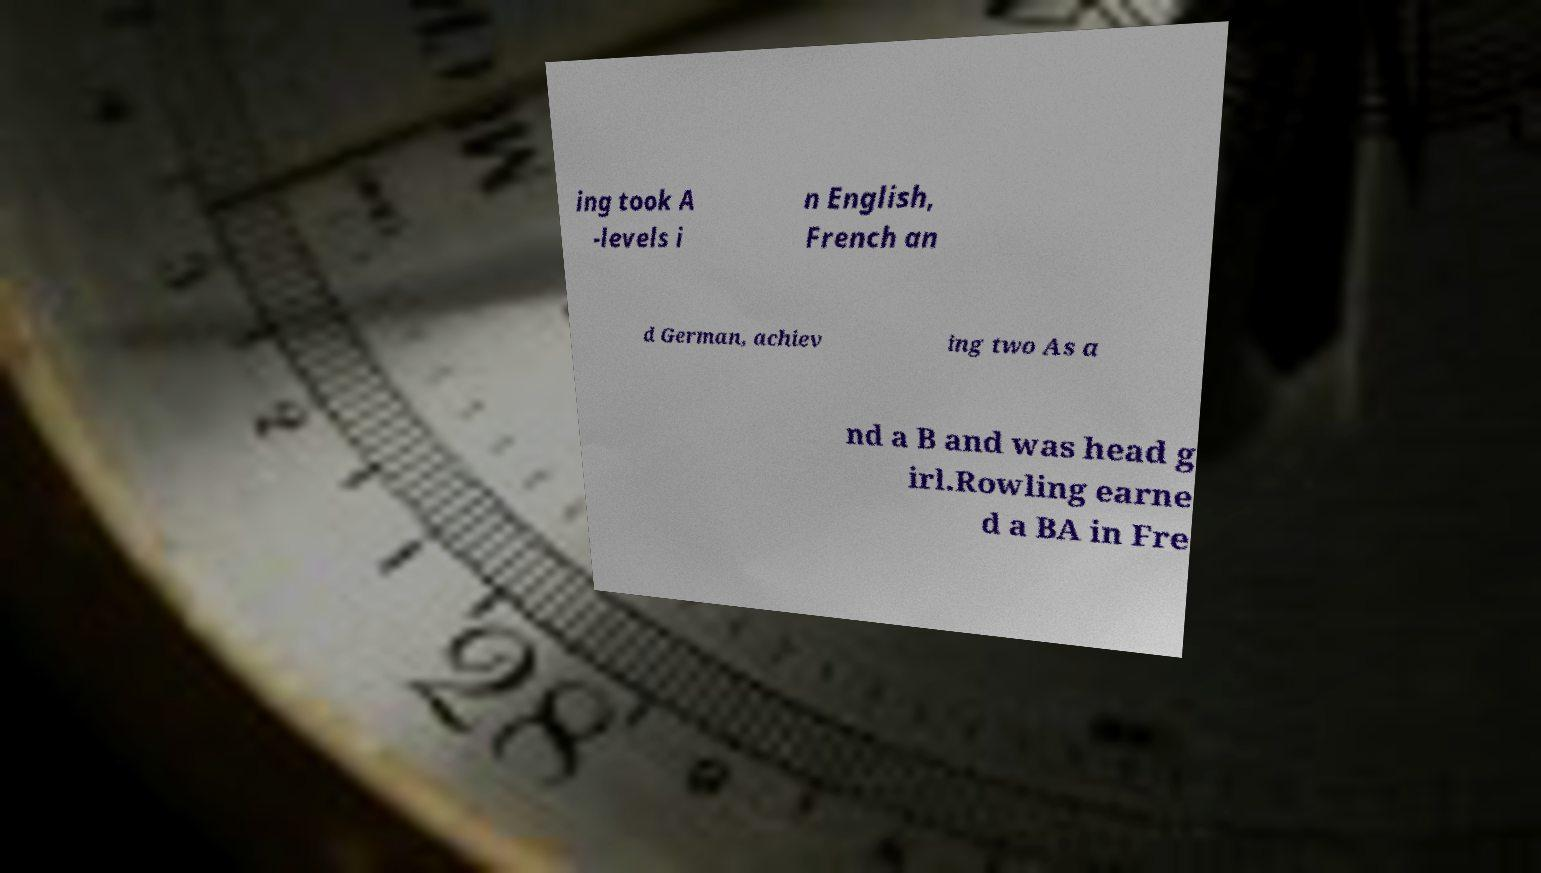Can you accurately transcribe the text from the provided image for me? ing took A -levels i n English, French an d German, achiev ing two As a nd a B and was head g irl.Rowling earne d a BA in Fre 